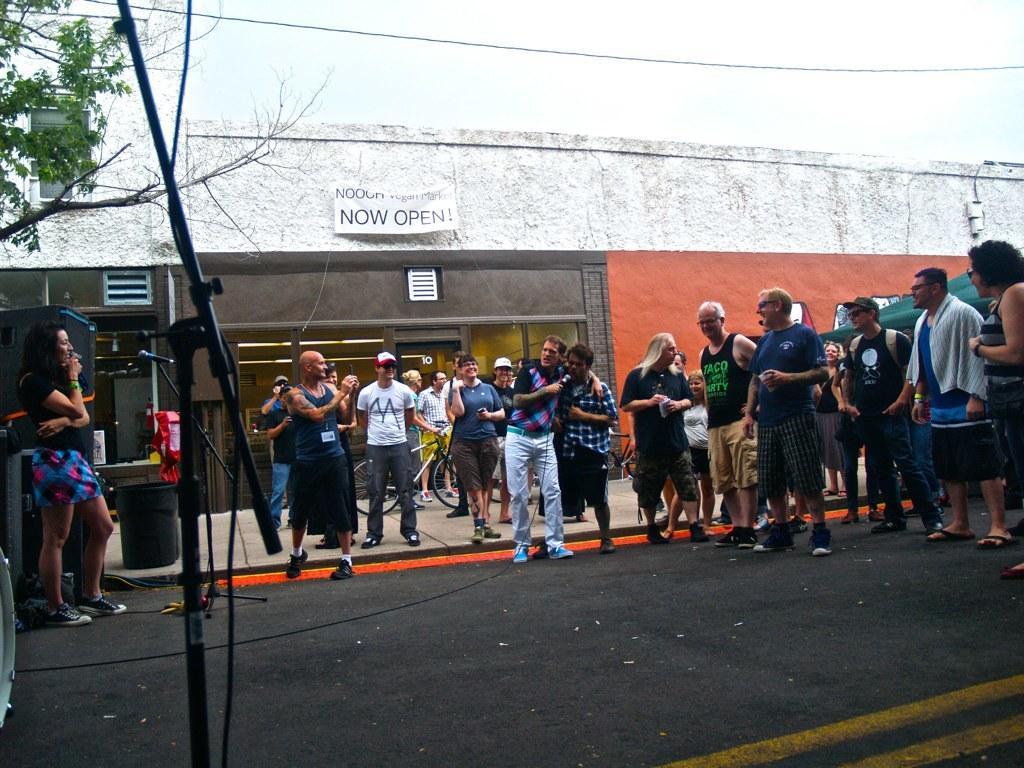Please provide a concise description of this image. in this image there is a group of persons standing in middle of this image, and there is a Mic stand at left side of this image. There is a building in the background and there is a board some text written on it at top of this image,and there is a tree at left side of this image and there is a road at bottom of this image and there is a sky at top of this image. 